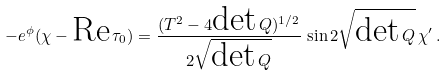Convert formula to latex. <formula><loc_0><loc_0><loc_500><loc_500>- e ^ { \phi } ( \chi - \text {Re} \, \tau _ { 0 } ) = \frac { ( T ^ { 2 } - 4 \text {det} \, Q ) ^ { 1 / 2 } } { 2 \sqrt { \text {det} \, Q } } \, \sin 2 \sqrt { \text {det} \, Q } \, \chi ^ { \prime } \, .</formula> 